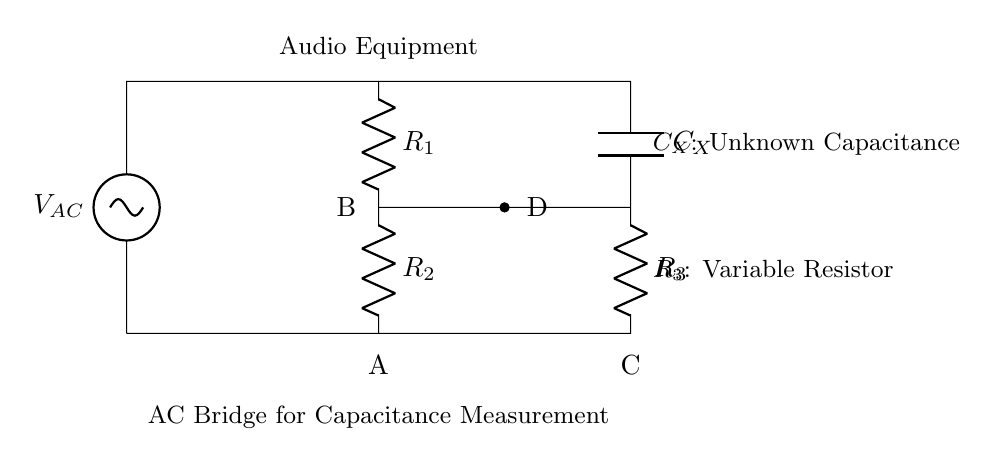What is the type of current source in this circuit? The circuit features an AC voltage source labeled V_AC at the top, indicating it provides alternating current.
Answer: AC What is the role of resistor R_3 in the circuit? Resistor R_3 is labeled as a variable resistor, which means it can be adjusted to help balance the bridge and measure unknown capacitance accurately.
Answer: Variable resistor Which component represents the unknown capacitance? The component labeled C_X is identified as the unknown capacitance in the circuit, which is what we're trying to measure using the bridge.
Answer: C_X What is the purpose of the connections labeled A, B, C, and D? The labels A, B, C, and D signify points in the bridge circuit where measurements can be made or connections can be established for analyzing voltages or currents.
Answer: Measurement points How does the circuit achieve balance in the bridge? The balance in an AC bridge circuit is achieved when the ratio of resistances R_1 and R_2 equals the ratio of resistance R_3 and the capacitive reactance of C_X at a certain frequency, allowing the voltage across points B and D to be zero.
Answer: Ratio of resistances and reactance What type of analysis is primarily performed with this circuit? This circuit primarily performs capacitance measurement for audio equipment, particularly to test capacitors in the context of their impedance characteristics at audio frequencies.
Answer: Capacitance measurement 